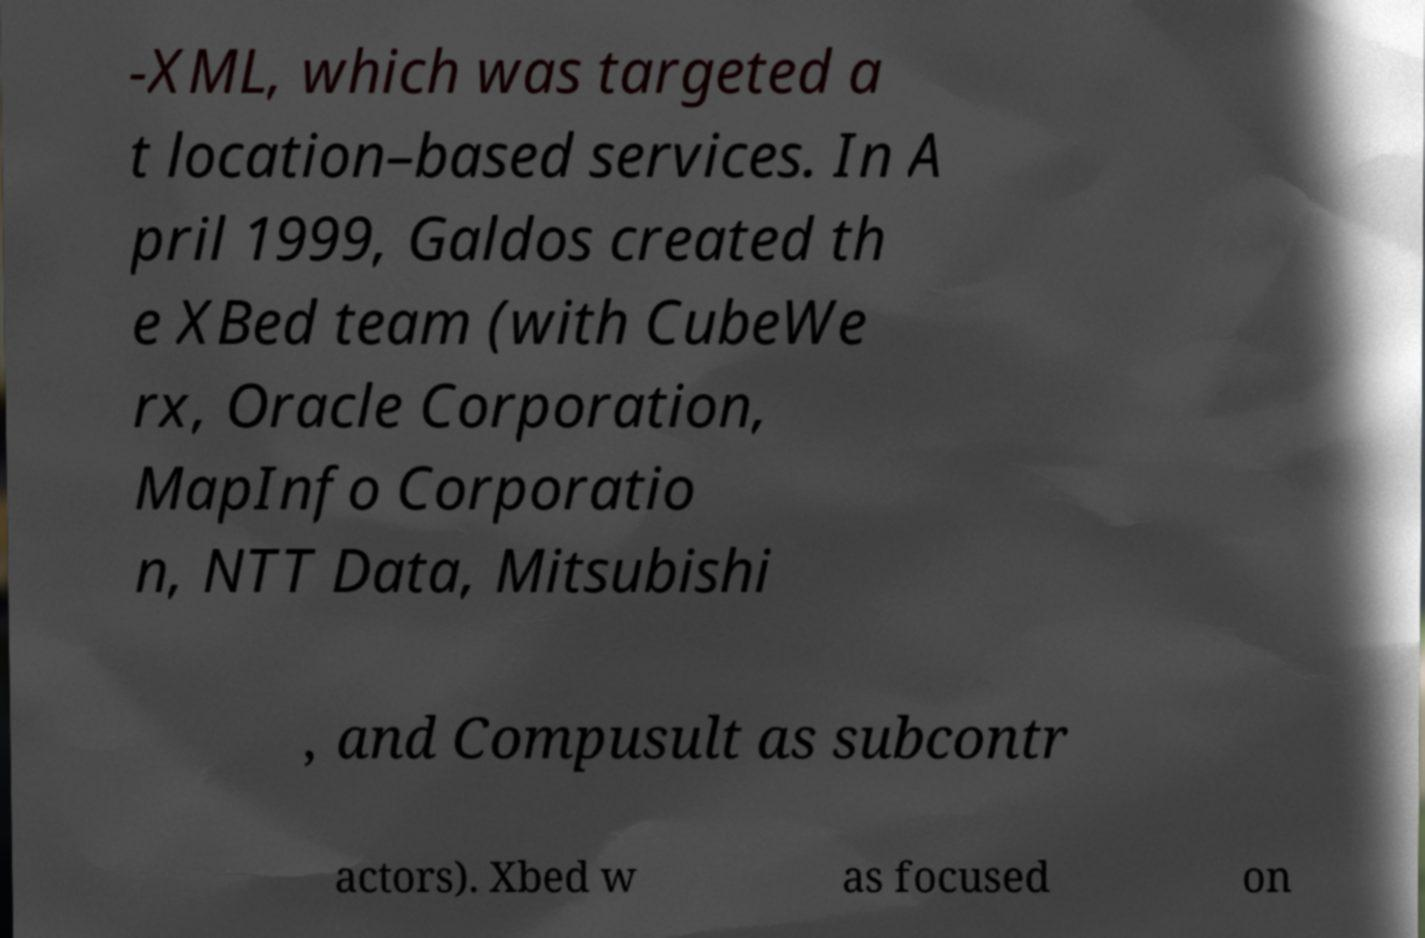Please read and relay the text visible in this image. What does it say? -XML, which was targeted a t location–based services. In A pril 1999, Galdos created th e XBed team (with CubeWe rx, Oracle Corporation, MapInfo Corporatio n, NTT Data, Mitsubishi , and Compusult as subcontr actors). Xbed w as focused on 